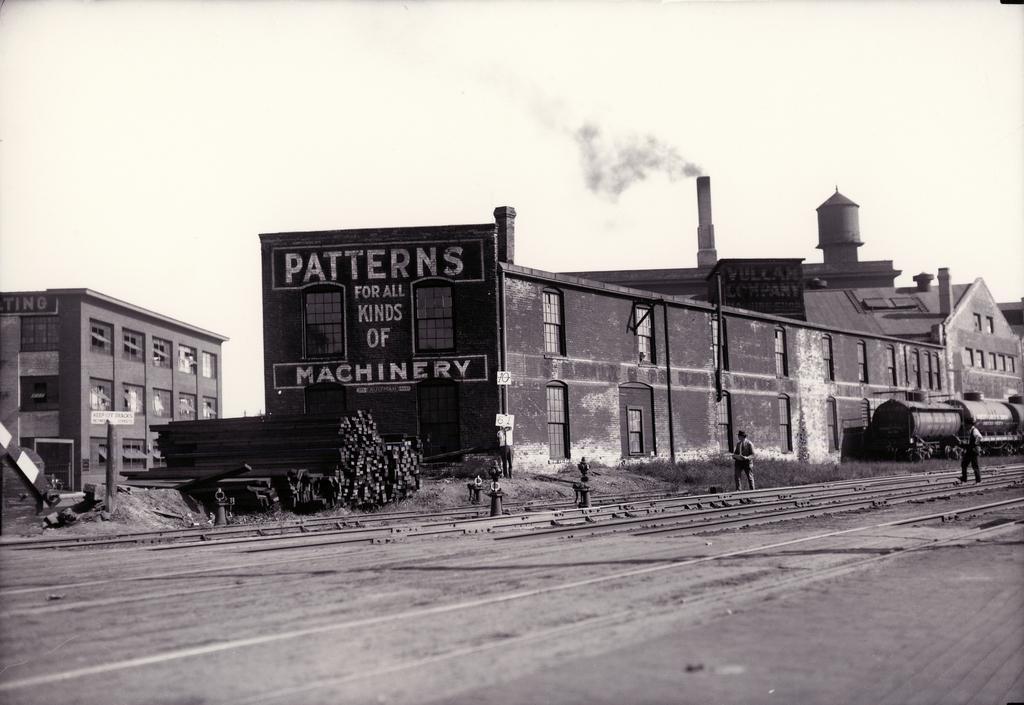Describe this image in one or two sentences. This is a black and white image. I can see two people walking. This looks like a train. I can see buildings with windows. These are the rail tracks. I think these are the iron bars. 